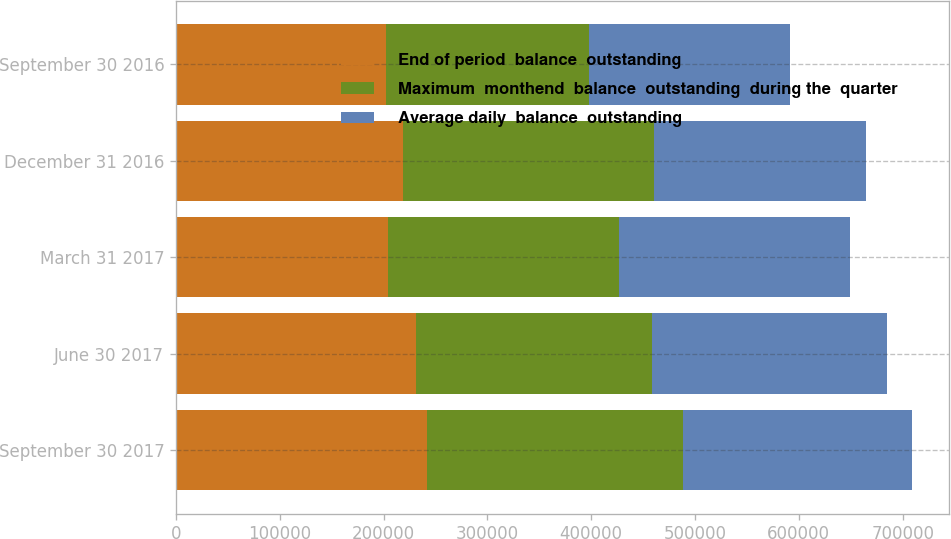<chart> <loc_0><loc_0><loc_500><loc_500><stacked_bar_chart><ecel><fcel>September 30 2017<fcel>June 30 2017<fcel>March 31 2017<fcel>December 31 2016<fcel>September 30 2016<nl><fcel>End of period  balance  outstanding<fcel>241365<fcel>231378<fcel>204623<fcel>219095<fcel>202687<nl><fcel>Maximum  monthend  balance  outstanding  during the  quarter<fcel>247048<fcel>226972<fcel>222476<fcel>241773<fcel>195551<nl><fcel>Average daily  balance  outstanding<fcel>220942<fcel>226972<fcel>222476<fcel>203378<fcel>193229<nl></chart> 